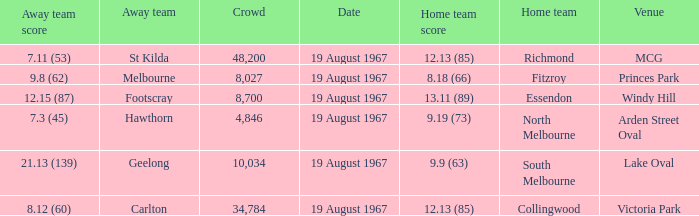What did the away team score when they were playing collingwood? 8.12 (60). 